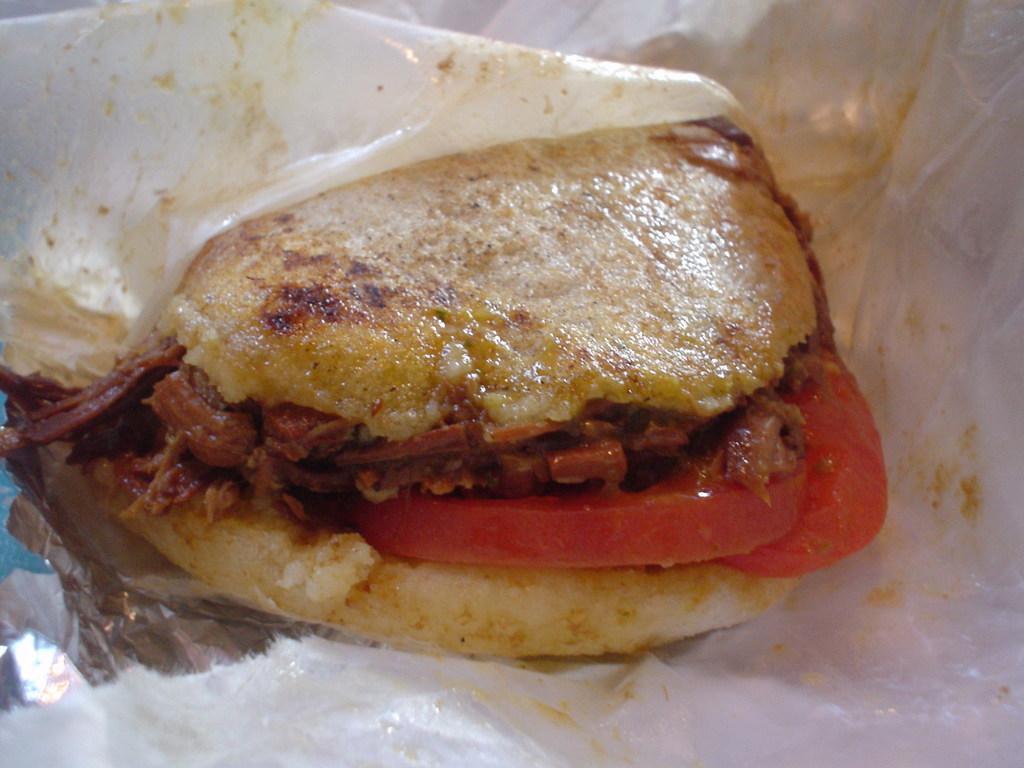In one or two sentences, can you explain what this image depicts? In this picture we can see food and an aluminum foil paper. 